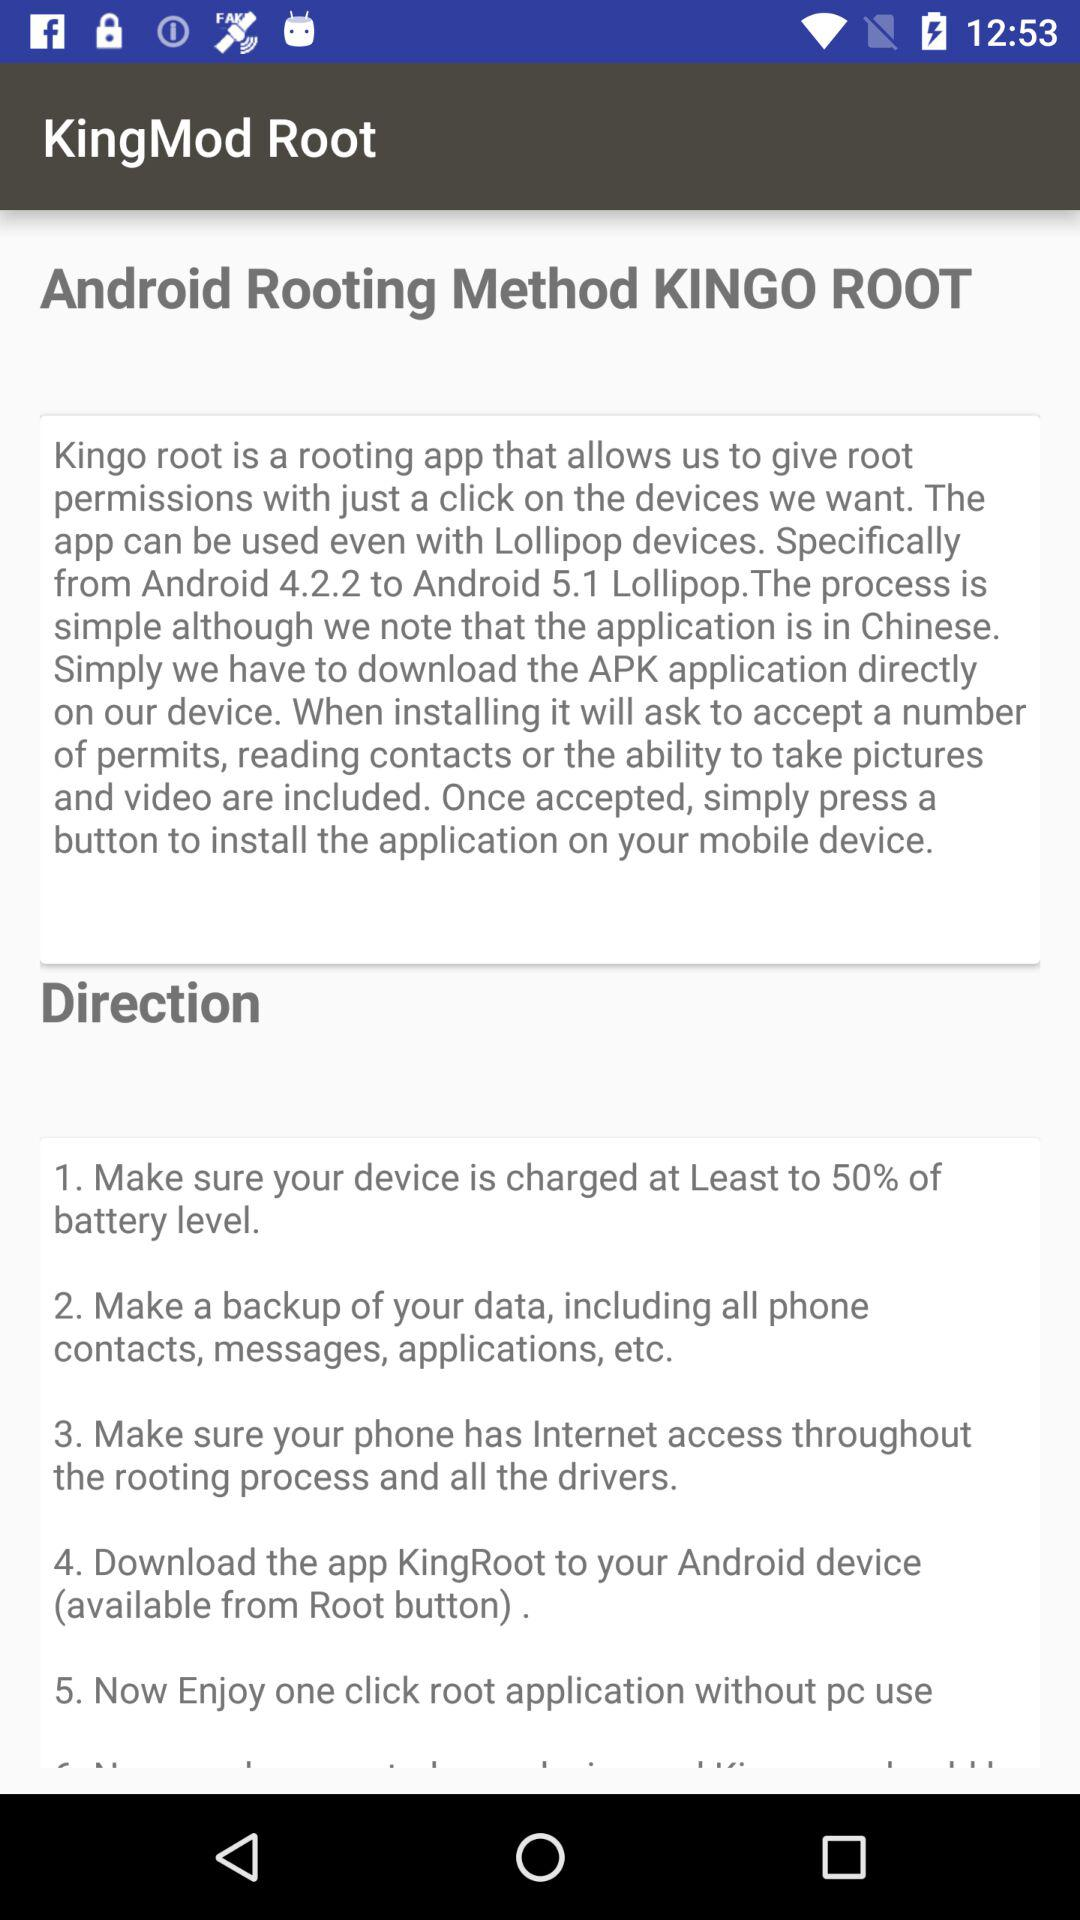What is the name of the application? The name of the application is "KingMod Root". 